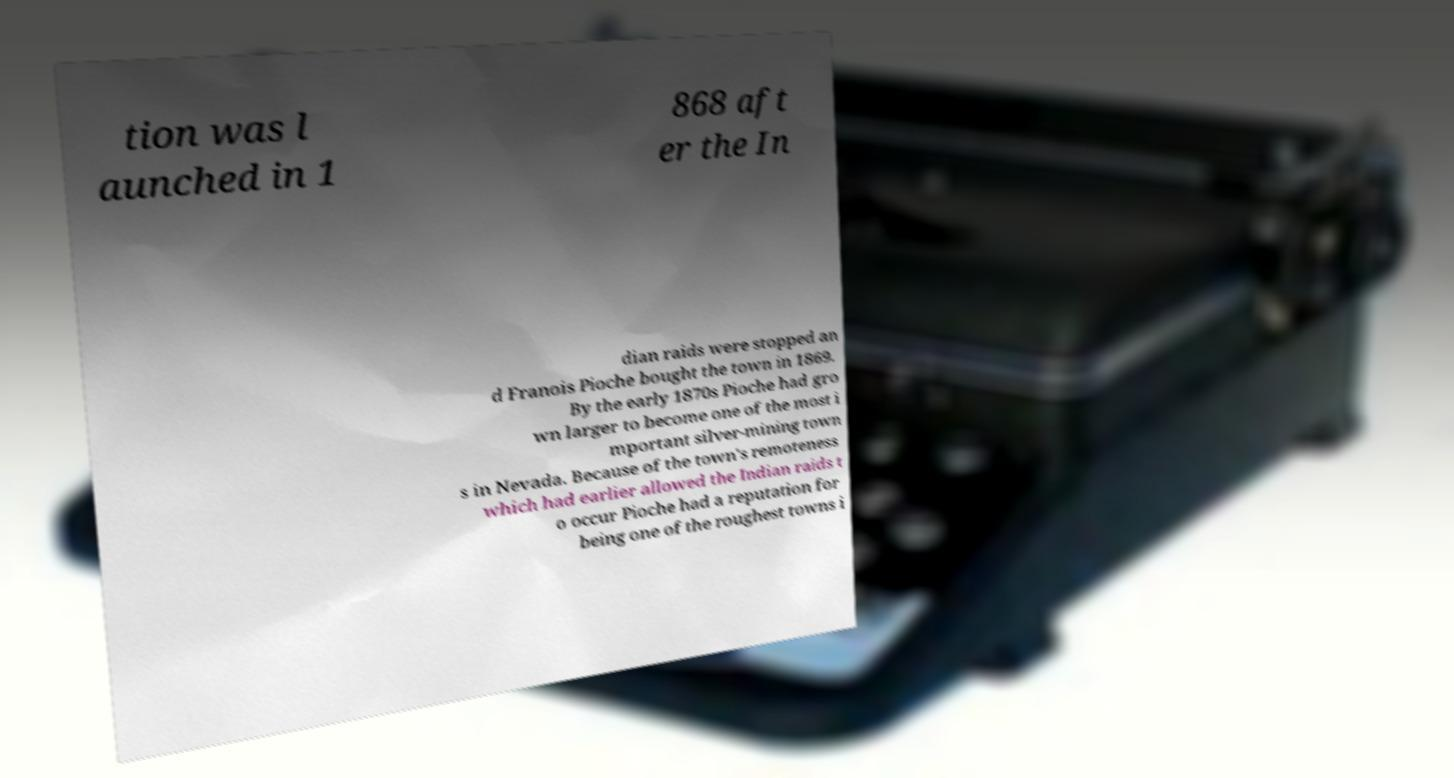I need the written content from this picture converted into text. Can you do that? tion was l aunched in 1 868 aft er the In dian raids were stopped an d Franois Pioche bought the town in 1869. By the early 1870s Pioche had gro wn larger to become one of the most i mportant silver-mining town s in Nevada. Because of the town's remoteness which had earlier allowed the Indian raids t o occur Pioche had a reputation for being one of the roughest towns i 